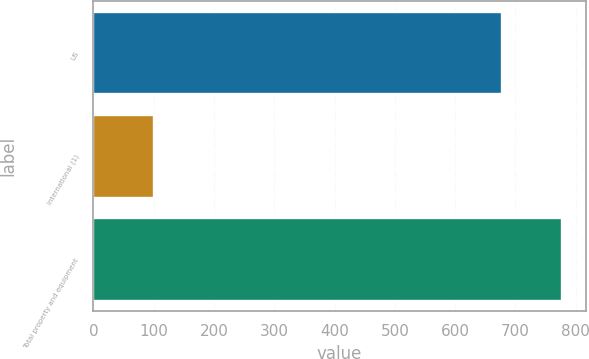<chart> <loc_0><loc_0><loc_500><loc_500><bar_chart><fcel>US<fcel>International (1)<fcel>Total property and equipment<nl><fcel>677<fcel>101<fcel>778<nl></chart> 